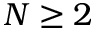Convert formula to latex. <formula><loc_0><loc_0><loc_500><loc_500>N \geq 2</formula> 